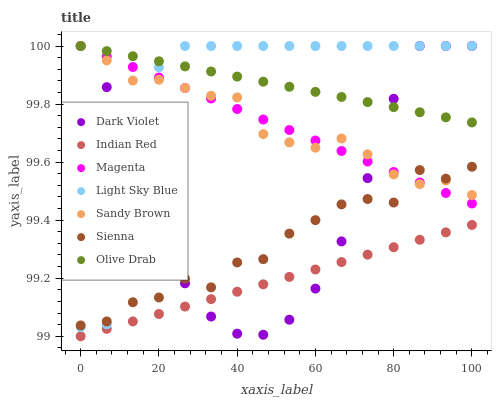Does Indian Red have the minimum area under the curve?
Answer yes or no. Yes. Does Olive Drab have the maximum area under the curve?
Answer yes or no. Yes. Does Sienna have the minimum area under the curve?
Answer yes or no. No. Does Sienna have the maximum area under the curve?
Answer yes or no. No. Is Magenta the smoothest?
Answer yes or no. Yes. Is Light Sky Blue the roughest?
Answer yes or no. Yes. Is Sienna the smoothest?
Answer yes or no. No. Is Sienna the roughest?
Answer yes or no. No. Does Indian Red have the lowest value?
Answer yes or no. Yes. Does Sienna have the lowest value?
Answer yes or no. No. Does Olive Drab have the highest value?
Answer yes or no. Yes. Does Sienna have the highest value?
Answer yes or no. No. Is Indian Red less than Sandy Brown?
Answer yes or no. Yes. Is Sienna greater than Indian Red?
Answer yes or no. Yes. Does Olive Drab intersect Dark Violet?
Answer yes or no. Yes. Is Olive Drab less than Dark Violet?
Answer yes or no. No. Is Olive Drab greater than Dark Violet?
Answer yes or no. No. Does Indian Red intersect Sandy Brown?
Answer yes or no. No. 